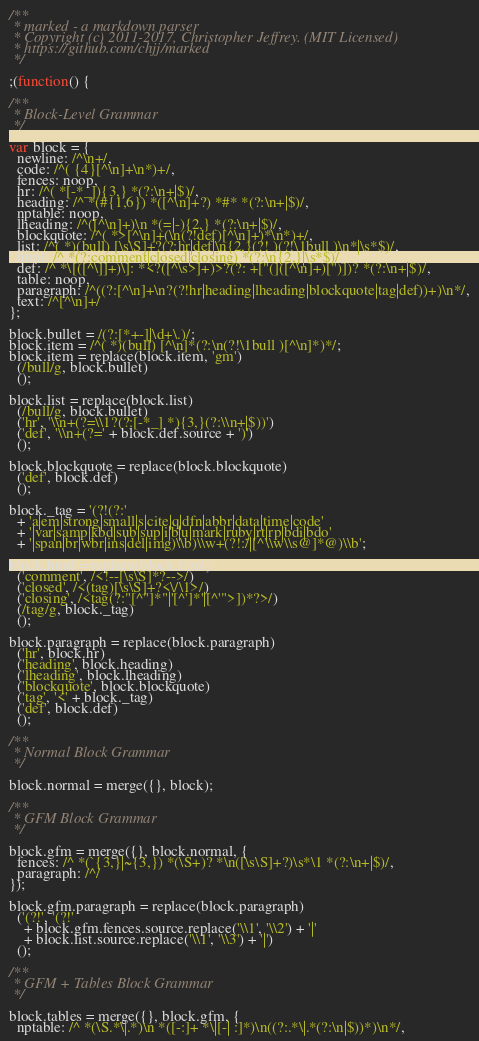Convert code to text. <code><loc_0><loc_0><loc_500><loc_500><_JavaScript_>/**
 * marked - a markdown parser
 * Copyright (c) 2011-2017, Christopher Jeffrey. (MIT Licensed)
 * https://github.com/chjj/marked
 */

;(function() {

/**
 * Block-Level Grammar
 */

var block = {
  newline: /^\n+/,
  code: /^( {4}[^\n]+\n*)+/,
  fences: noop,
  hr: /^( *[-*_]){3,} *(?:\n+|$)/,
  heading: /^ *(#{1,6}) *([^\n]+?) *#* *(?:\n+|$)/,
  nptable: noop,
  lheading: /^([^\n]+)\n *(=|-){2,} *(?:\n+|$)/,
  blockquote: /^( *>[^\n]+(\n(?!def)[^\n]+)*\n*)+/,
  list: /^( *)(bull) [\s\S]+?(?:hr|def|\n{2,}(?! )(?!\1bull )\n*|\s*$)/,
  html: /^ *(?:comment|closed|closing) *(?:\n{2,}|\s*$)/,
  def: /^ *\[([^\]]+)\]: *<?([^\s>]+)>?(?: +["(]([^\n]+)[")])? *(?:\n+|$)/,
  table: noop,
  paragraph: /^((?:[^\n]+\n?(?!hr|heading|lheading|blockquote|tag|def))+)\n*/,
  text: /^[^\n]+/
};

block.bullet = /(?:[*+-]|\d+\.)/;
block.item = /^( *)(bull) [^\n]*(?:\n(?!\1bull )[^\n]*)*/;
block.item = replace(block.item, 'gm')
  (/bull/g, block.bullet)
  ();

block.list = replace(block.list)
  (/bull/g, block.bullet)
  ('hr', '\\n+(?=\\1?(?:[-*_] *){3,}(?:\\n+|$))')
  ('def', '\\n+(?=' + block.def.source + ')')
  ();

block.blockquote = replace(block.blockquote)
  ('def', block.def)
  ();

block._tag = '(?!(?:'
  + 'a|em|strong|small|s|cite|q|dfn|abbr|data|time|code'
  + '|var|samp|kbd|sub|sup|i|b|u|mark|ruby|rt|rp|bdi|bdo'
  + '|span|br|wbr|ins|del|img)\\b)\\w+(?!:/|[^\\w\\s@]*@)\\b';

block.html = replace(block.html)
  ('comment', /<!--[\s\S]*?-->/)
  ('closed', /<(tag)[\s\S]+?<\/\1>/)
  ('closing', /<tag(?:"[^"]*"|'[^']*'|[^'">])*?>/)
  (/tag/g, block._tag)
  ();

block.paragraph = replace(block.paragraph)
  ('hr', block.hr)
  ('heading', block.heading)
  ('lheading', block.lheading)
  ('blockquote', block.blockquote)
  ('tag', '<' + block._tag)
  ('def', block.def)
  ();

/**
 * Normal Block Grammar
 */

block.normal = merge({}, block);

/**
 * GFM Block Grammar
 */

block.gfm = merge({}, block.normal, {
  fences: /^ *(`{3,}|~{3,}) *(\S+)? *\n([\s\S]+?)\s*\1 *(?:\n+|$)/,
  paragraph: /^/
});

block.gfm.paragraph = replace(block.paragraph)
  ('(?!', '(?!'
    + block.gfm.fences.source.replace('\\1', '\\2') + '|'
    + block.list.source.replace('\\1', '\\3') + '|')
  ();

/**
 * GFM + Tables Block Grammar
 */

block.tables = merge({}, block.gfm, {
  nptable: /^ *(\S.*\|.*)\n *([-:]+ *\|[-| :]*)\n((?:.*\|.*(?:\n|$))*)\n*/,</code> 